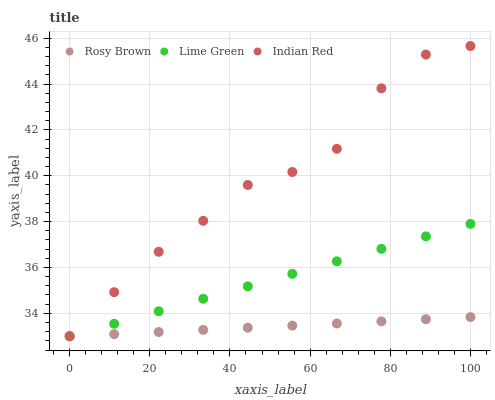Does Rosy Brown have the minimum area under the curve?
Answer yes or no. Yes. Does Indian Red have the maximum area under the curve?
Answer yes or no. Yes. Does Lime Green have the minimum area under the curve?
Answer yes or no. No. Does Lime Green have the maximum area under the curve?
Answer yes or no. No. Is Rosy Brown the smoothest?
Answer yes or no. Yes. Is Indian Red the roughest?
Answer yes or no. Yes. Is Lime Green the smoothest?
Answer yes or no. No. Is Lime Green the roughest?
Answer yes or no. No. Does Rosy Brown have the lowest value?
Answer yes or no. Yes. Does Indian Red have the highest value?
Answer yes or no. Yes. Does Lime Green have the highest value?
Answer yes or no. No. Does Rosy Brown intersect Lime Green?
Answer yes or no. Yes. Is Rosy Brown less than Lime Green?
Answer yes or no. No. Is Rosy Brown greater than Lime Green?
Answer yes or no. No. 